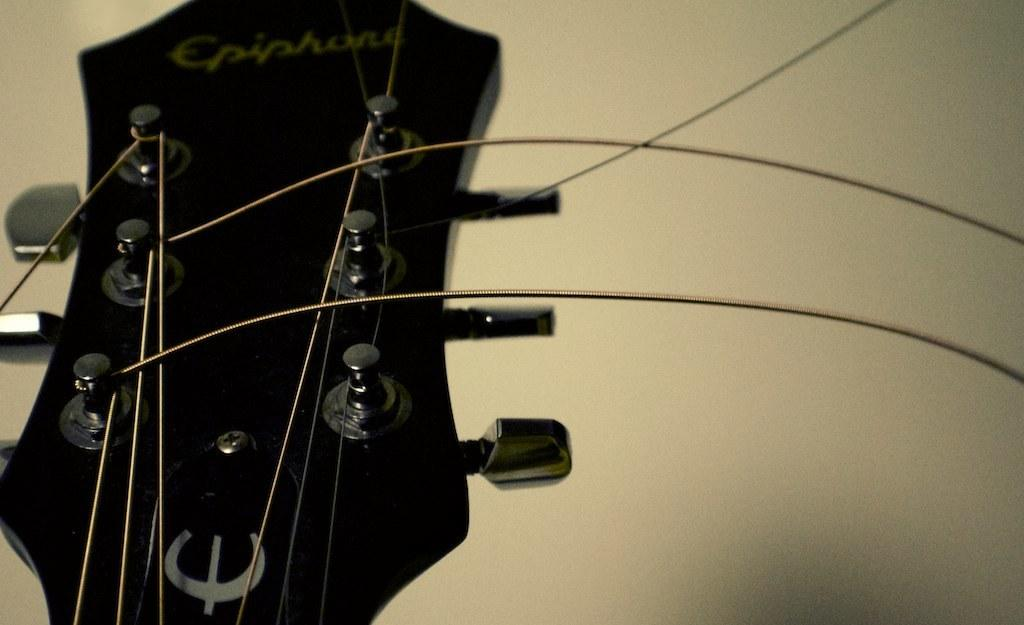What is the main object in the center of the image? There is a guitar in the center of the image. What feature of the guitar is mentioned in the facts? The guitar has strings. What can be seen in the background of the image? There is a wall in the background of the image. What type of copper tray is placed on the wall in the image? There is no copper tray present in the image; it only features a guitar with strings and a wall in the background. 